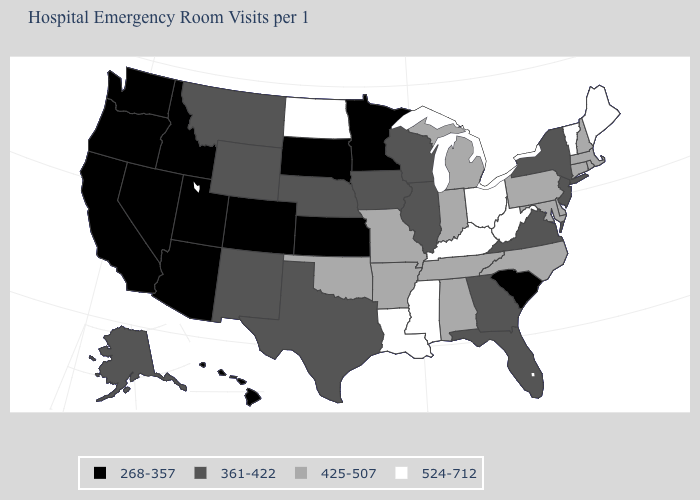What is the value of New York?
Short answer required. 361-422. Name the states that have a value in the range 361-422?
Answer briefly. Alaska, Florida, Georgia, Illinois, Iowa, Montana, Nebraska, New Jersey, New Mexico, New York, Texas, Virginia, Wisconsin, Wyoming. What is the value of Virginia?
Short answer required. 361-422. Which states have the highest value in the USA?
Answer briefly. Kentucky, Louisiana, Maine, Mississippi, North Dakota, Ohio, Vermont, West Virginia. Which states hav the highest value in the West?
Keep it brief. Alaska, Montana, New Mexico, Wyoming. Name the states that have a value in the range 524-712?
Short answer required. Kentucky, Louisiana, Maine, Mississippi, North Dakota, Ohio, Vermont, West Virginia. Does Nevada have the highest value in the West?
Concise answer only. No. What is the highest value in the South ?
Concise answer only. 524-712. What is the value of Arkansas?
Answer briefly. 425-507. Name the states that have a value in the range 361-422?
Give a very brief answer. Alaska, Florida, Georgia, Illinois, Iowa, Montana, Nebraska, New Jersey, New Mexico, New York, Texas, Virginia, Wisconsin, Wyoming. What is the value of Rhode Island?
Concise answer only. 425-507. Among the states that border Kentucky , does Illinois have the lowest value?
Keep it brief. Yes. Does Massachusetts have the same value as Nevada?
Keep it brief. No. Which states have the lowest value in the South?
Concise answer only. South Carolina. Which states have the highest value in the USA?
Short answer required. Kentucky, Louisiana, Maine, Mississippi, North Dakota, Ohio, Vermont, West Virginia. 